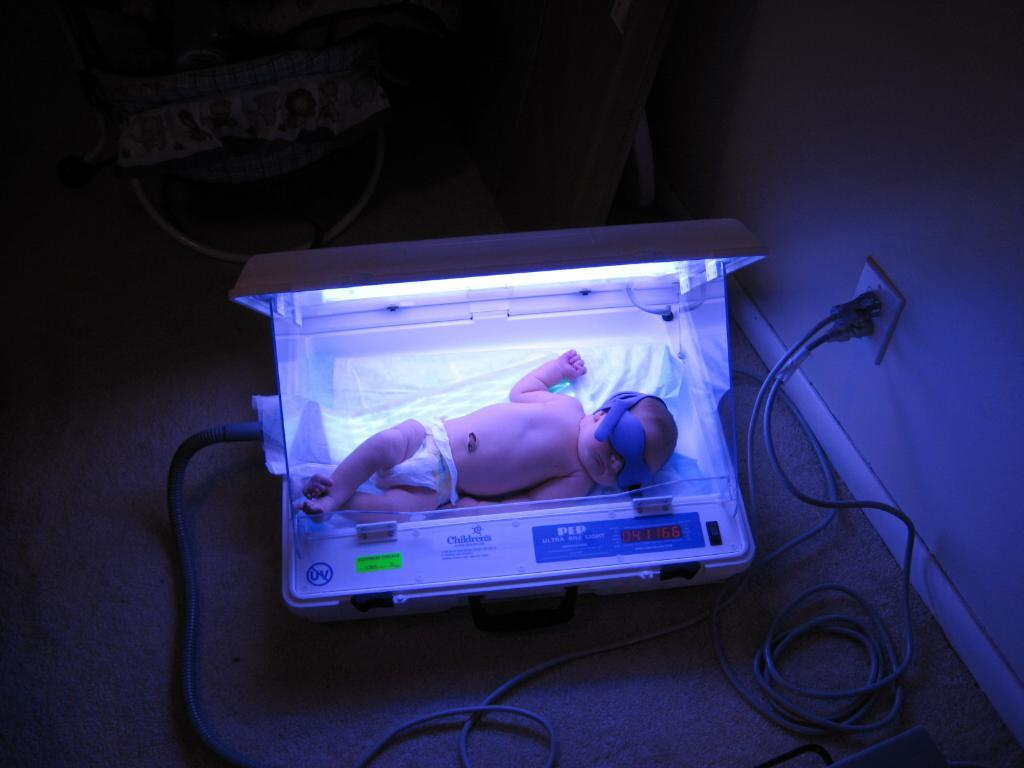What is one of the main features of the image? There is a wall in the image. What can be found on the wall? There is a switch board in the image. What is connected to the switch board? There are wires in the image. Who is present in the image? There is a child in the image. What type of equipment is visible in the image? There is an electrical equipment in the image. What color is the rabbit's lip in the image? There is no rabbit or lip present in the image. What direction is the child facing in the image? The direction the child is facing cannot be determined from the image alone, as it only shows the child's body and not their head. 